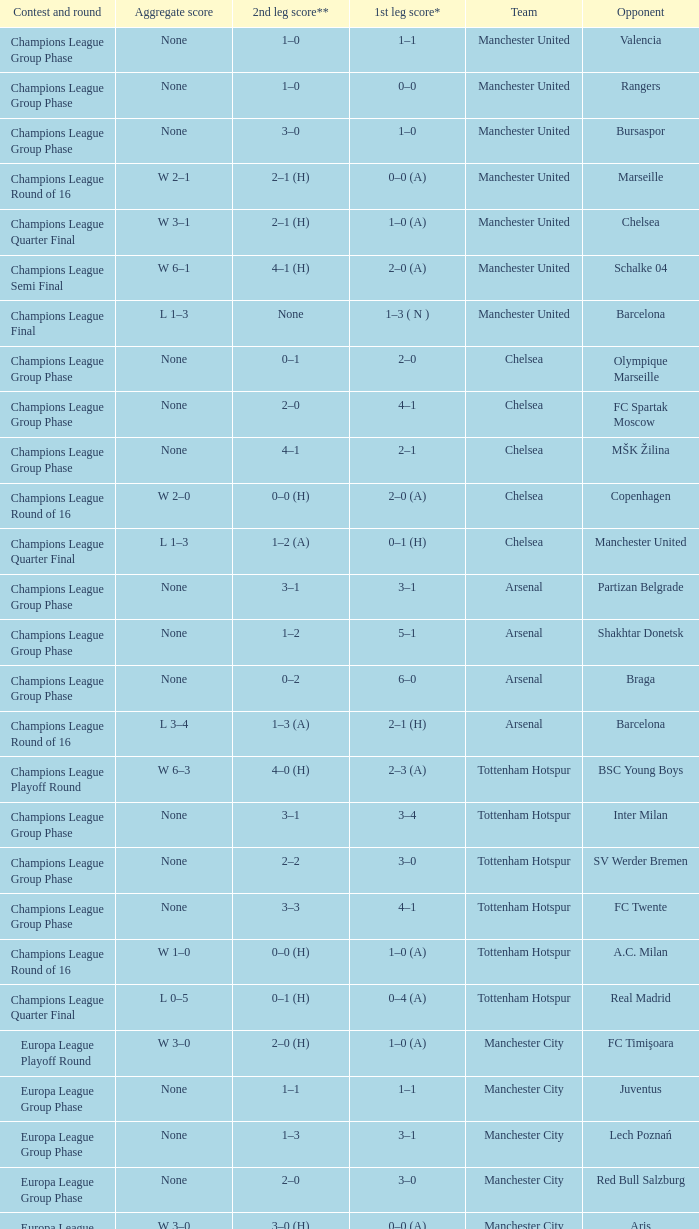How many goals did each team score in the first leg of the match between Liverpool and Steaua Bucureşti? 4–1. 